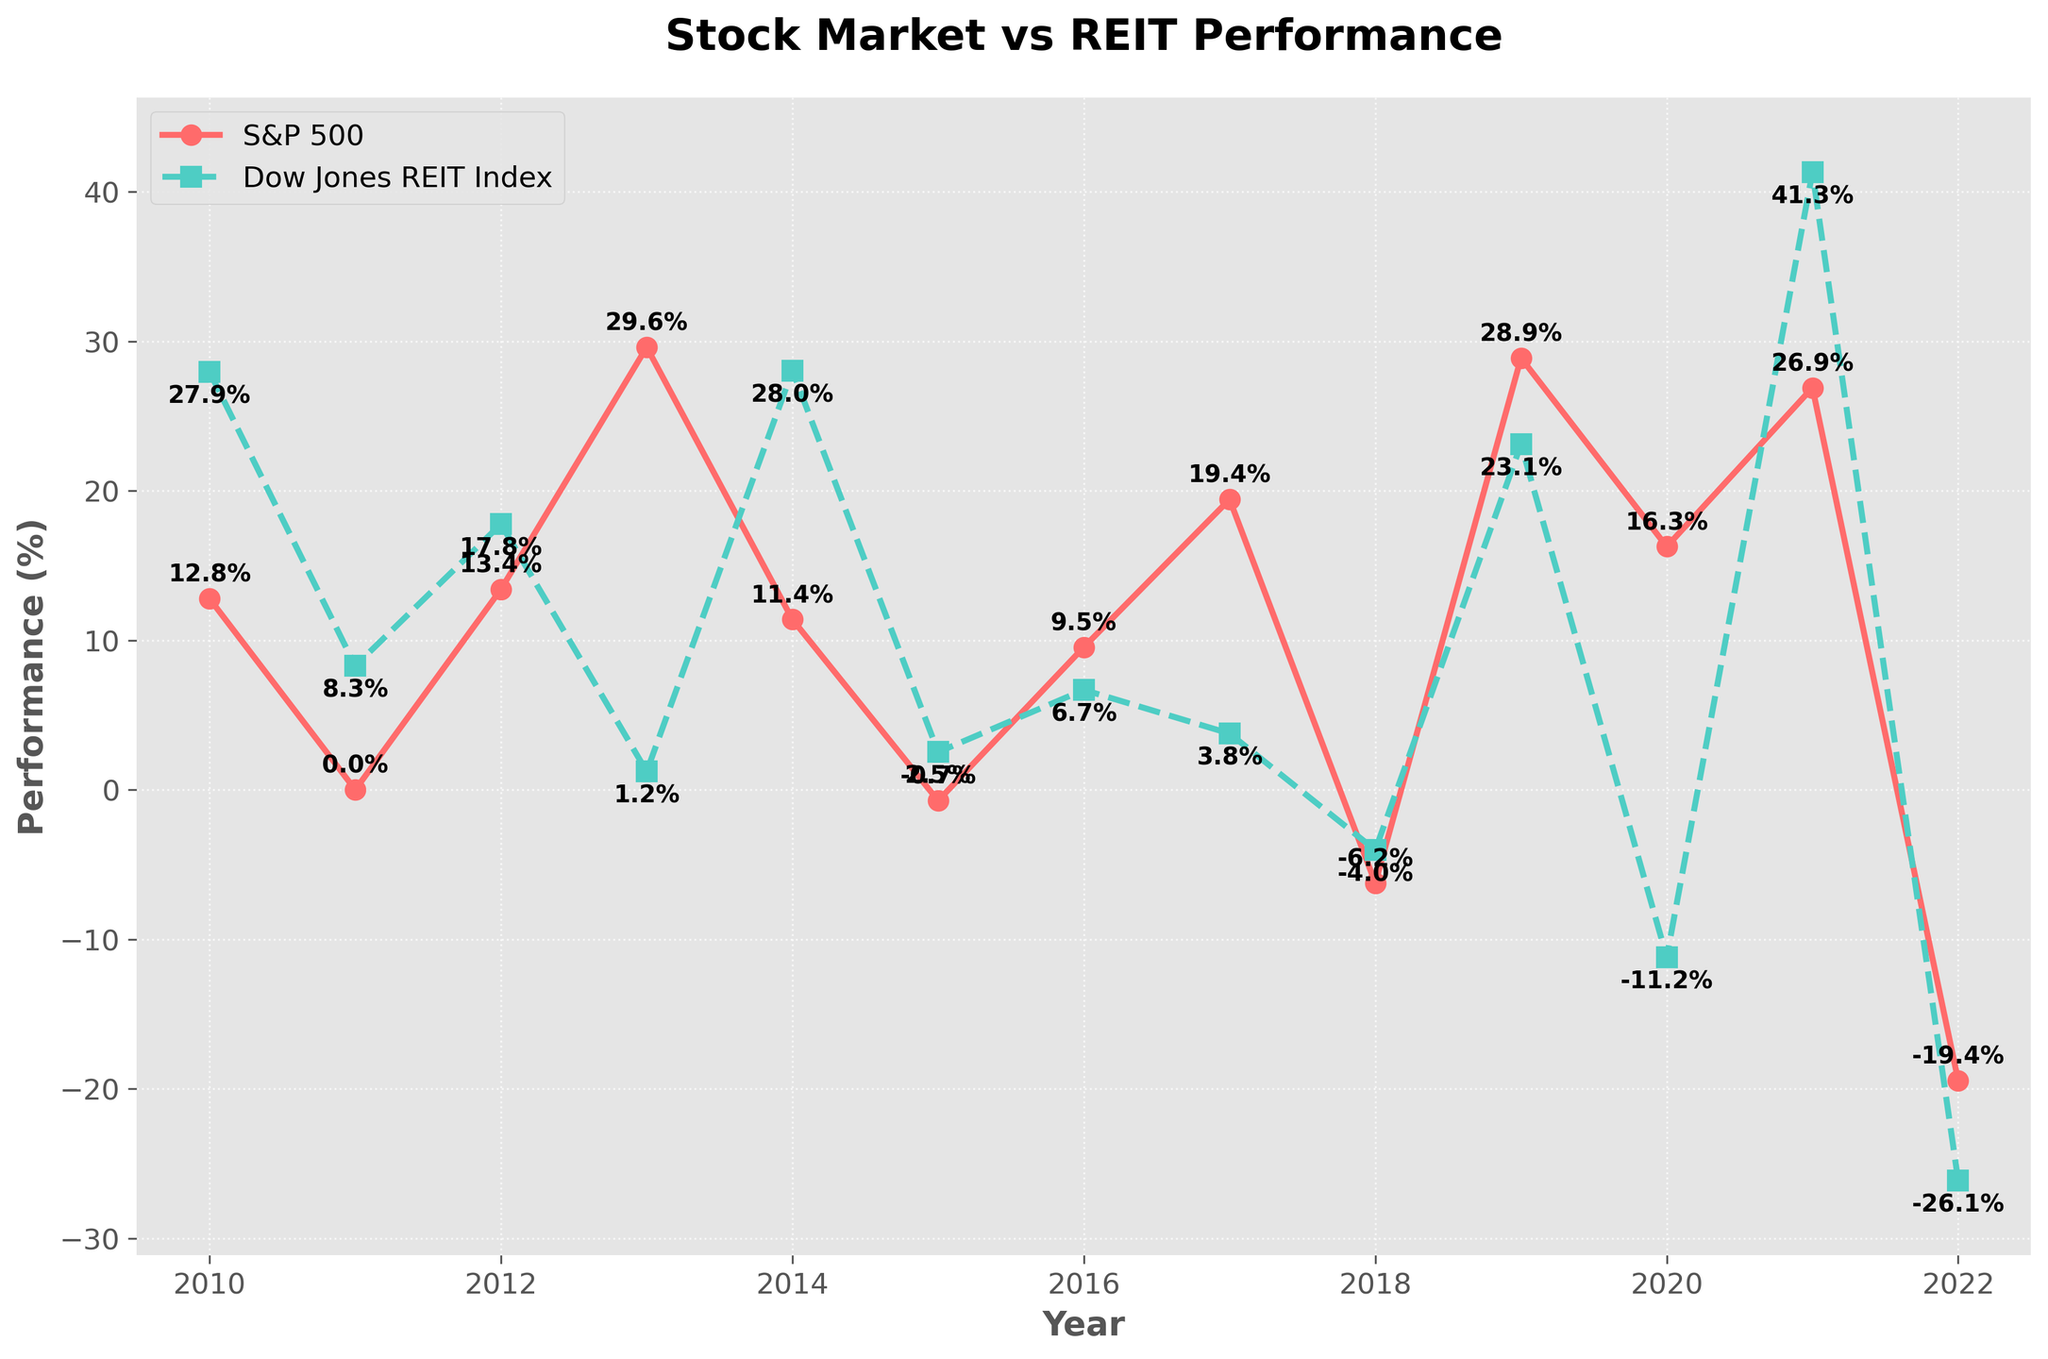What's the highest performance recorded for S&P 500? Look at the line representing S&P 500 and identify the peak point. The highest performance recorded is in 2013 with 29.6%.
Answer: 29.6% Which year did the Dow Jones REIT Index perform the worst? Observe the line corresponding to the Dow Jones REIT Index and locate the lowest point on the chart. The lowest performance was in 2022 at -26.13%.
Answer: 2022 In how many years was the performance of the Dow Jones REIT Index higher than the S&P 500? Compare both lines year by year, noting when the Dow Jones REIT Index is above the S&P 500. These years are 2010, 2011, 2012, 2014, 2015, and 2021. There are 6 such years.
Answer: 6 years What is the difference in performance between S&P 500 and REIT for the year 2020? Identify the values for 2020: 16.26% for S&P 500 and -11.2% for REIT. Calculate the difference: 16.26% - (-11.2%) = 27.46%.
Answer: 27.46% On average, which index performed better over the period shown? Calculate the average performance for both indices by summing all values and dividing by the number of years. The S&P 500's average is 10.77% and Dow Jones REIT Index's average is 9.71%. S&P 500 performed better.
Answer: S&P 500 Which index showed a greater variability in performance over the years? Assess the fluctuations in the data by visually comparing the variations in the lines. Dow Jones REIT Index shows greater up and down variability compared to the more stable S&P 500 line.
Answer: REIT Identify the year where both indices had negative performance. Look at the chart and pinpoint the years where both the S&P 500 and Dow Jones REIT Index lines fall below 0%. The year is 2018.
Answer: 2018 What is the combined performance of S&P 500 and REIT in 2011? Add the performance values of both indices for 2011: 0.00% (S&P 500) + 8.28% (REIT) = 8.28%.
Answer: 8.28% By how much did REIT outperform S&P 500 in 2014? Identify the values for 2014: 11.39% (S&P 500) and 28.03% (REIT). Calculate the difference: 28.03% - 11.39% = 16.64%.
Answer: 16.64% Is there any year where S&P 500 and REIT have almost equal performance? Scan the chart for years where the performance lines are close to each other. The closest values are in 2019 with 28.88% (S&P 500) and 23.10% (REIT), but no year shows nearly equal performance.
Answer: No 